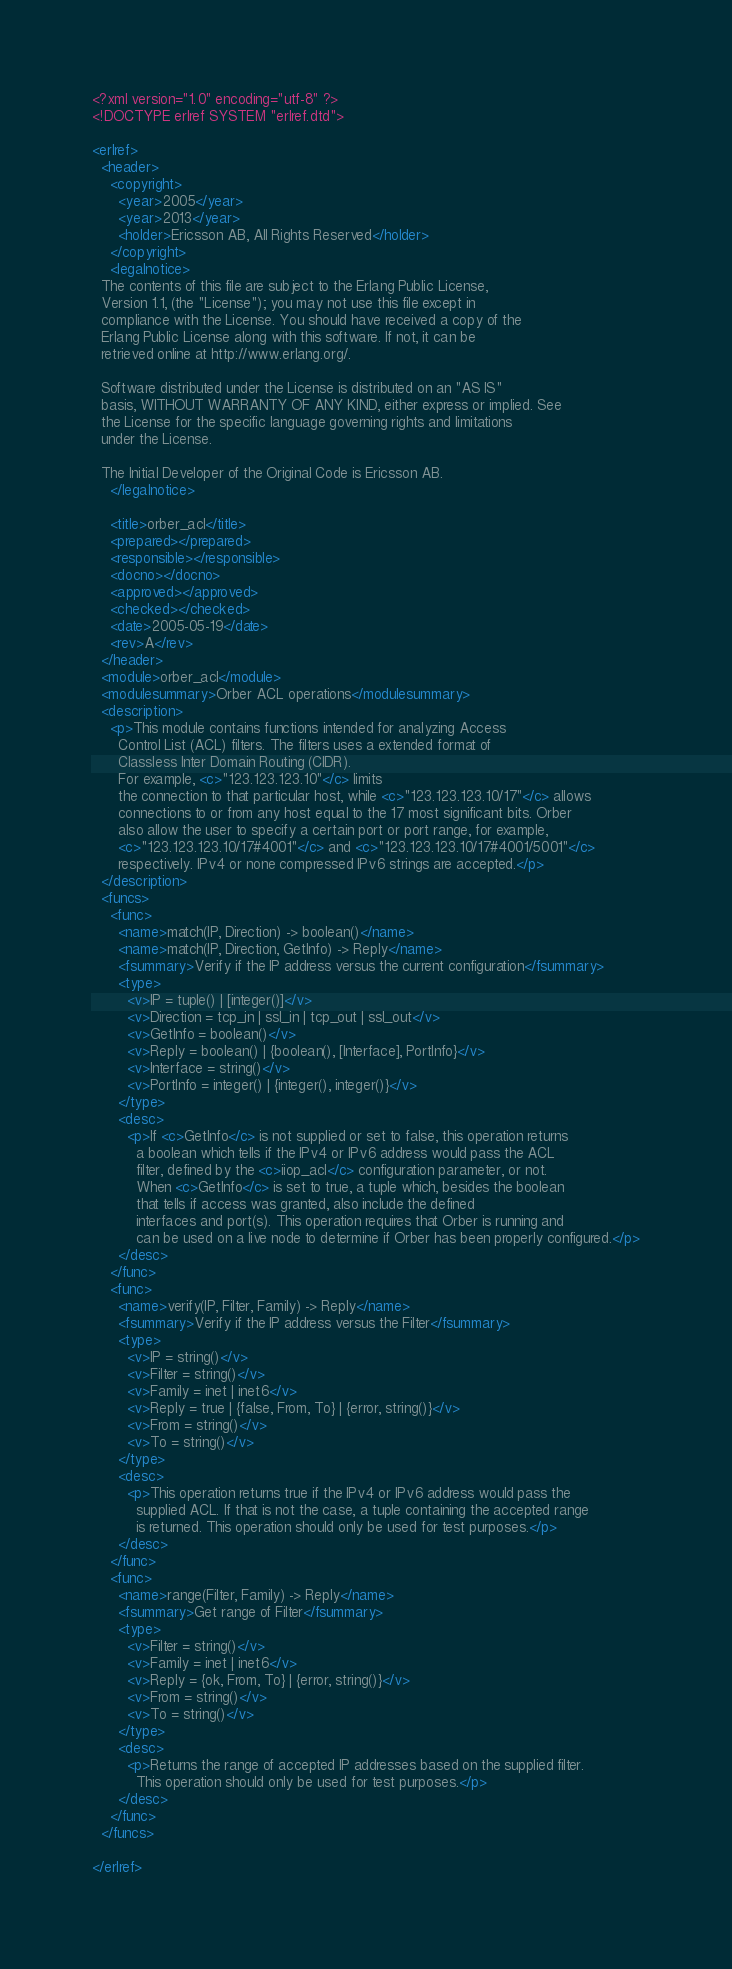Convert code to text. <code><loc_0><loc_0><loc_500><loc_500><_XML_><?xml version="1.0" encoding="utf-8" ?>
<!DOCTYPE erlref SYSTEM "erlref.dtd">

<erlref>
  <header>
    <copyright>
      <year>2005</year>
      <year>2013</year>
      <holder>Ericsson AB, All Rights Reserved</holder>
    </copyright>
    <legalnotice>
  The contents of this file are subject to the Erlang Public License,
  Version 1.1, (the "License"); you may not use this file except in
  compliance with the License. You should have received a copy of the
  Erlang Public License along with this software. If not, it can be
  retrieved online at http://www.erlang.org/.

  Software distributed under the License is distributed on an "AS IS"
  basis, WITHOUT WARRANTY OF ANY KIND, either express or implied. See
  the License for the specific language governing rights and limitations
  under the License.

  The Initial Developer of the Original Code is Ericsson AB.
    </legalnotice>

    <title>orber_acl</title>
    <prepared></prepared>
    <responsible></responsible>
    <docno></docno>
    <approved></approved>
    <checked></checked>
    <date>2005-05-19</date>
    <rev>A</rev>
  </header>
  <module>orber_acl</module>
  <modulesummary>Orber ACL operations</modulesummary>
  <description>
    <p>This module contains functions intended for analyzing Access 
      Control List (ACL) filters. The filters uses a extended format of 
      Classless Inter Domain Routing (CIDR). 
      For example, <c>"123.123.123.10"</c> limits
      the connection to that particular host, while <c>"123.123.123.10/17"</c> allows
      connections to or from any host equal to the 17 most significant bits. Orber
      also allow the user to specify a certain port or port range, for example,
      <c>"123.123.123.10/17#4001"</c> and <c>"123.123.123.10/17#4001/5001"</c>
      respectively. IPv4 or none compressed IPv6 strings are accepted.</p>
  </description>
  <funcs>
    <func>
      <name>match(IP, Direction) -> boolean()</name>
      <name>match(IP, Direction, GetInfo) -> Reply</name>
      <fsummary>Verify if the IP address versus the current configuration</fsummary>
      <type>
        <v>IP = tuple() | [integer()]</v>
        <v>Direction = tcp_in | ssl_in | tcp_out | ssl_out</v>
        <v>GetInfo = boolean()</v>
        <v>Reply = boolean() | {boolean(), [Interface], PortInfo}</v>
        <v>Interface = string()</v>
        <v>PortInfo = integer() | {integer(), integer()}</v>
      </type>
      <desc>
        <p>If <c>GetInfo</c> is not supplied or set to false, this operation returns
          a boolean which tells if the IPv4 or IPv6 address would pass the ACL
          filter, defined by the <c>iiop_acl</c> configuration parameter, or not.
          When <c>GetInfo</c> is set to true, a tuple which, besides the boolean
          that tells if access was granted, also include the defined
          interfaces and port(s). This operation requires that Orber is running and
          can be used on a live node to determine if Orber has been properly configured.</p>
      </desc>
    </func>
    <func>
      <name>verify(IP, Filter, Family) -> Reply</name>
      <fsummary>Verify if the IP address versus the Filter</fsummary>
      <type>
        <v>IP = string()</v>
        <v>Filter = string()</v>
        <v>Family = inet | inet6</v>
        <v>Reply = true | {false, From, To} | {error, string()}</v>
        <v>From = string()</v>
        <v>To = string()</v>
      </type>
      <desc>
        <p>This operation returns true if the IPv4 or IPv6 address would pass the
          supplied ACL. If that is not the case, a tuple containing the accepted range
          is returned. This operation should only be used for test purposes.</p>
      </desc>
    </func>
    <func>
      <name>range(Filter, Family) -> Reply</name>
      <fsummary>Get range of Filter</fsummary>
      <type>
        <v>Filter = string()</v>
        <v>Family = inet | inet6</v>
        <v>Reply = {ok, From, To} | {error, string()}</v>
        <v>From = string()</v>
        <v>To = string()</v>
      </type>
      <desc>
        <p>Returns the range of accepted IP addresses based on the supplied filter. 
          This operation should only be used for test purposes.</p>
      </desc>
    </func>
  </funcs>
  
</erlref>

</code> 